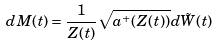Convert formula to latex. <formula><loc_0><loc_0><loc_500><loc_500>d M ( t ) = \frac { 1 } { Z ( t ) } \sqrt { a ^ { + } ( Z ( t ) ) } d \tilde { W } ( t )</formula> 